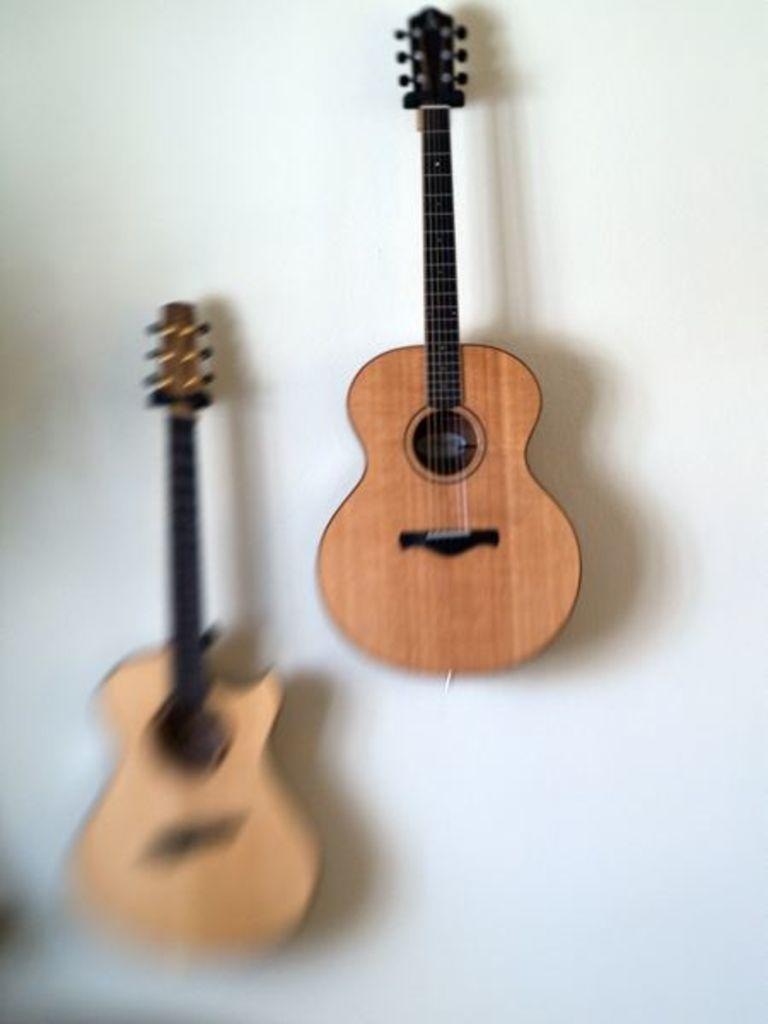How many guitars are in the picture? There are two guitars in the picture. What are the colors of the guitars? One guitar is brown in color, and the other guitar is black in color. How are the guitars positioned in the picture? The guitars are attached to the wall. What is the profit made from the alarm in the picture? There is no alarm present in the picture, so it's not possible to determine any profit made from it. 